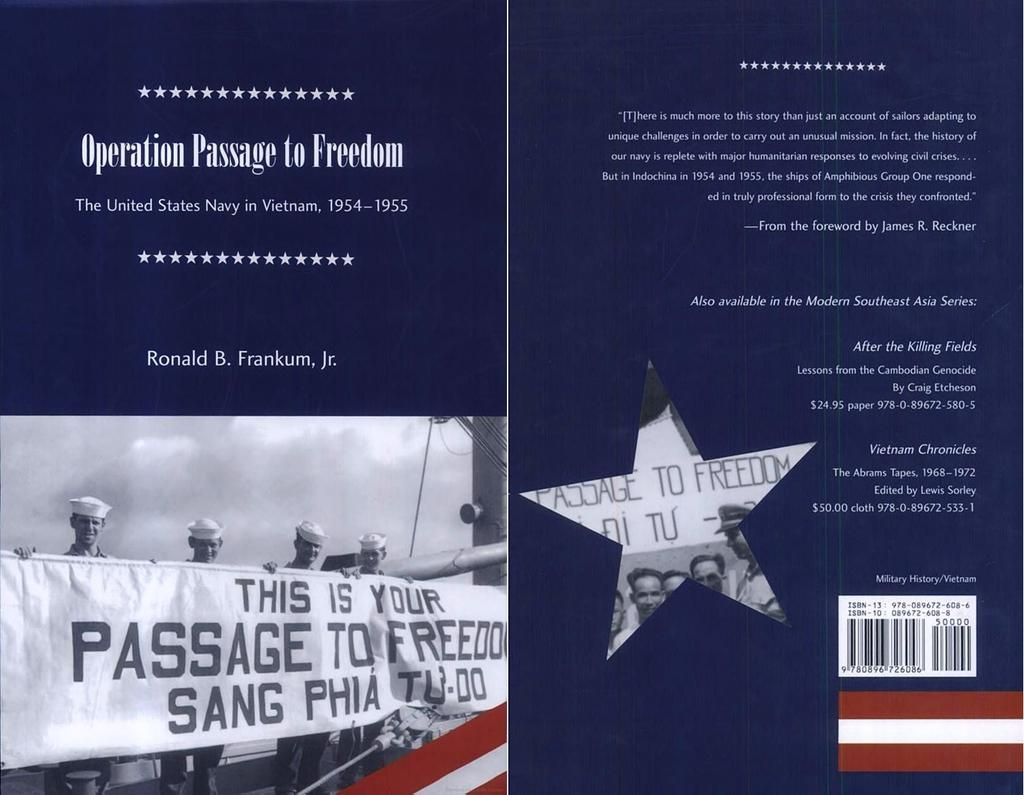<image>
Provide a brief description of the given image. Four men hold a sign that says, "This is your passage to freedom". 